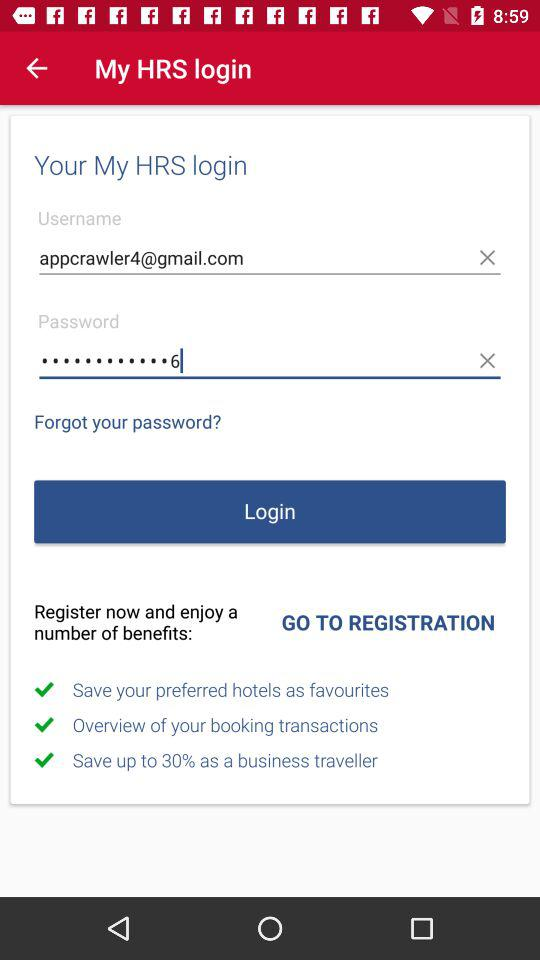What is the used email address? The email address is appcrawler4@gmail.com. 